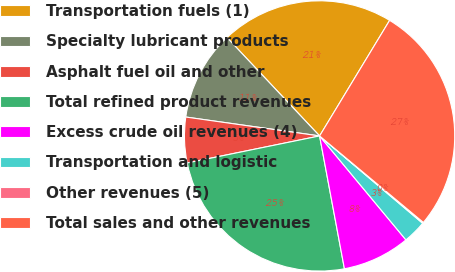Convert chart. <chart><loc_0><loc_0><loc_500><loc_500><pie_chart><fcel>Transportation fuels (1)<fcel>Specialty lubricant products<fcel>Asphalt fuel oil and other<fcel>Total refined product revenues<fcel>Excess crude oil revenues (4)<fcel>Transportation and logistic<fcel>Other revenues (5)<fcel>Total sales and other revenues<nl><fcel>20.69%<fcel>10.75%<fcel>5.44%<fcel>24.74%<fcel>8.09%<fcel>2.78%<fcel>0.13%<fcel>27.39%<nl></chart> 